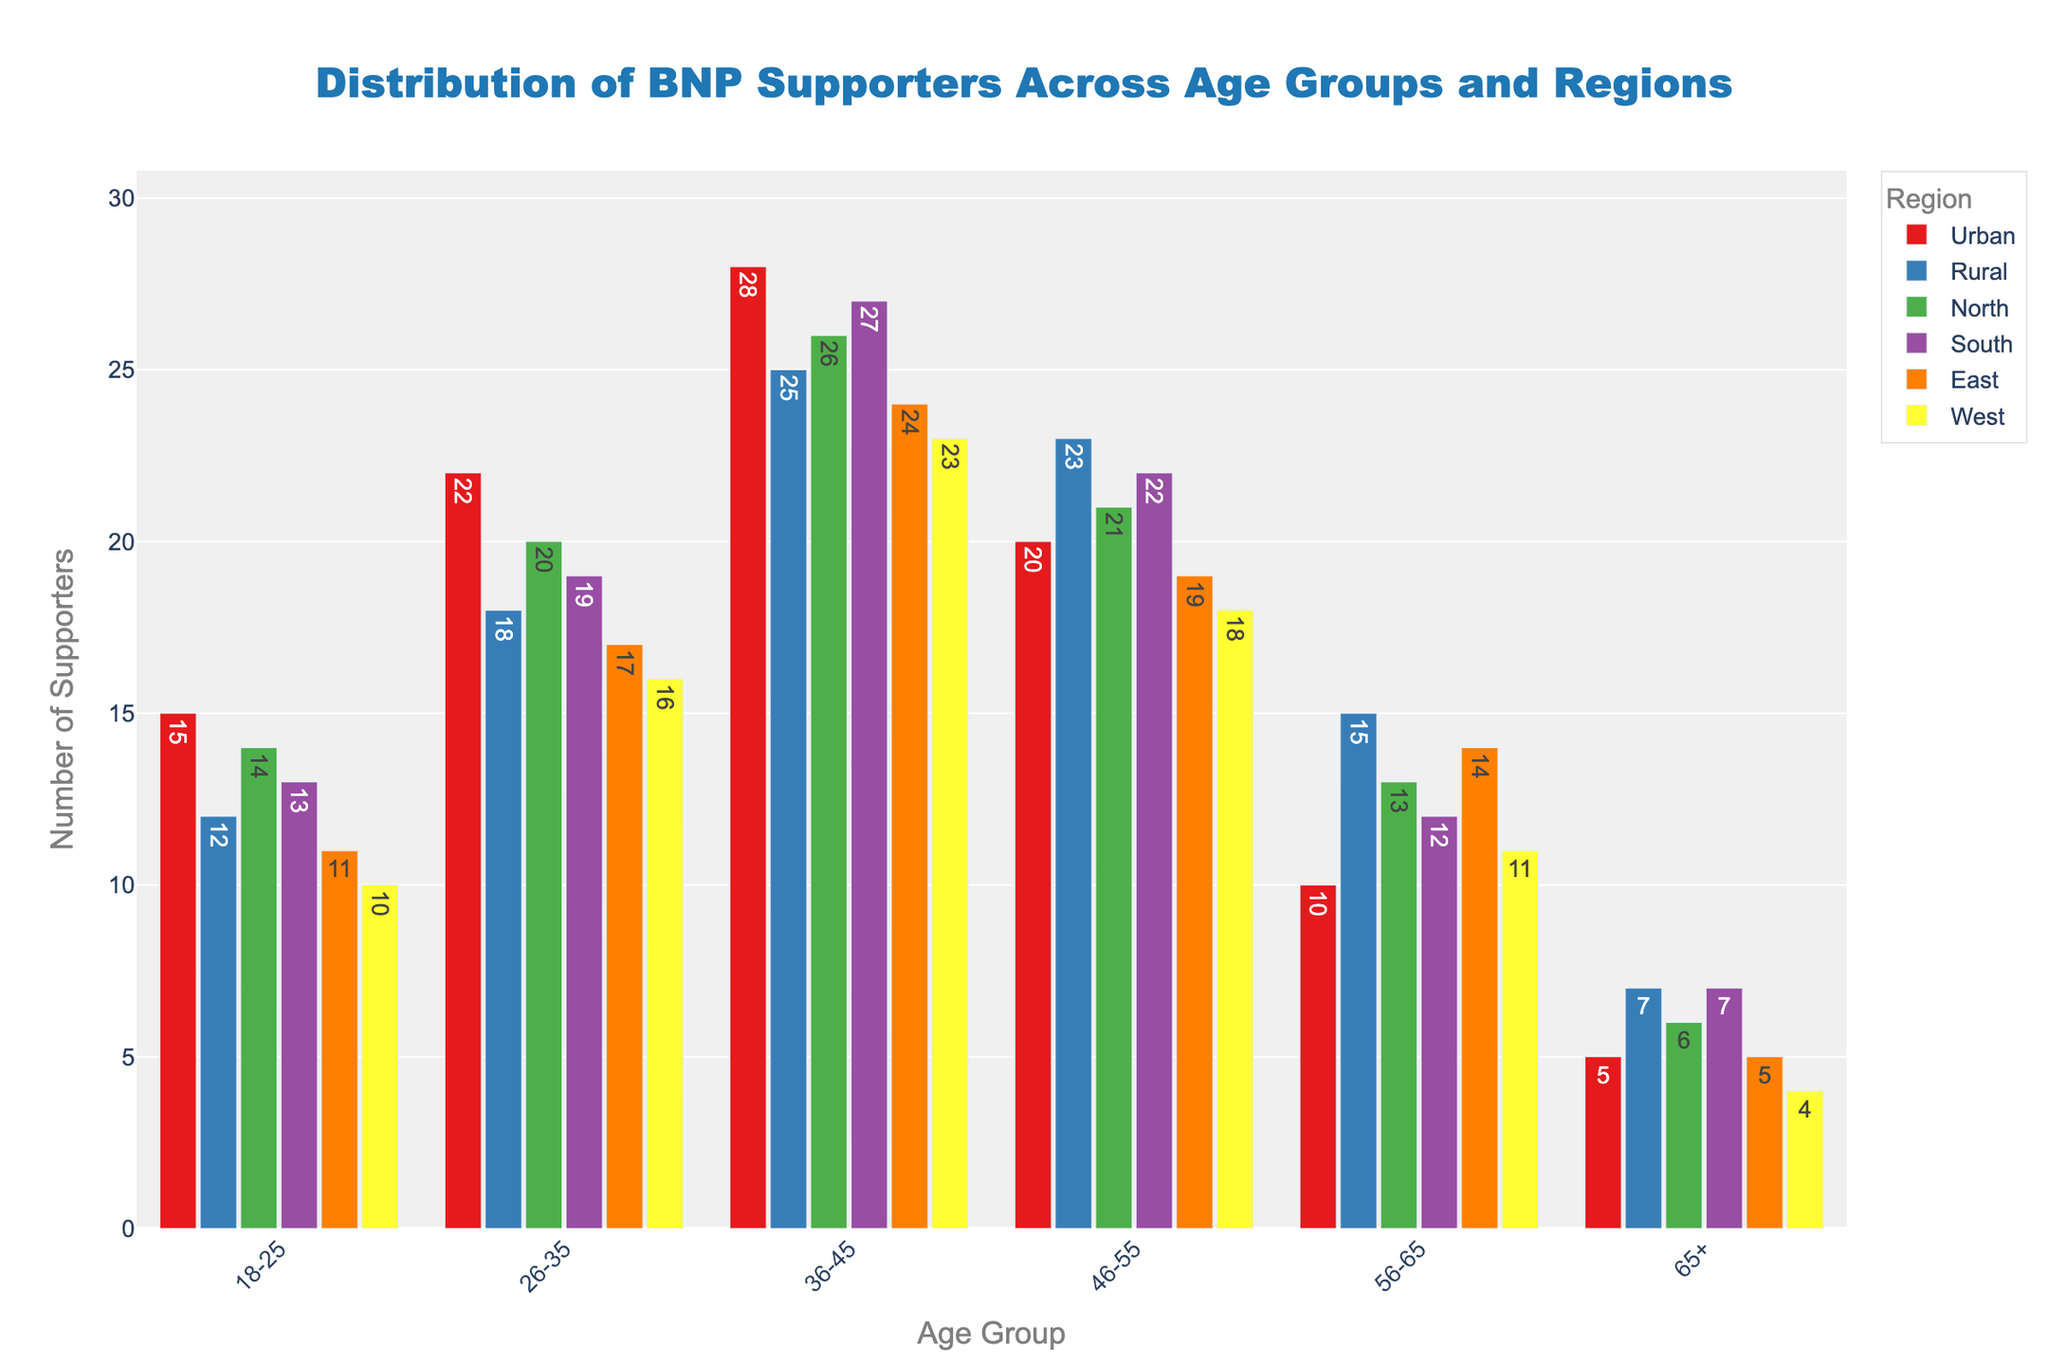Which age group has the highest number of BNP supporters in urban regions? Looking at the bars for urban regions, the age group 36-45 has the highest bar, indicating the largest number of supporters.
Answer: 36-45 Which region has the fewest BNP supporters aged 18-25? Looking at the bars for the age group 18-25, the West region has the lowest bar height, indicating the fewest supporters.
Answer: West What is the total number of BNP supporters in the 26-35 age group across all regions? Sum the number of supporters for the 26-35 age group in all regions: 22 (Urban) + 18 (Rural) + 20 (North) + 19 (South) + 17 (East) + 16 (West) = 112.
Answer: 112 In which region is the difference between supporters in the 36-45 and 46-55 age groups the least? Calculate the difference in the number of supporters between these age groups for each region: 
Urban: 28-20 = 8,
Rural: 25-23 = 2,
North: 26-21 = 5,
South: 27-22 = 5,
East: 24–19 = 5,
West: 23-18 = 5.
The difference is least in the Rural region.
Answer: Rural Which age group has the smallest range in the number of supporters across all regions? Find the range (max-min) for each age group:
18-25: max(15, 12, 14, 13, 11, 10) - min(15, 12, 14, 13, 11, 10) = 15 - 10 = 5,
26-35: max(22, 18, 20, 19, 17, 16) - min(22, 18, 20, 19, 17, 16) = 22 - 16 = 6,
36-45: max(28, 25, 26, 27, 24, 23) - min(28, 25, 26, 27, 24, 23) = 28 - 23 = 5,
46-55: max(23, 23, 21, 22, 19, 18) - min(23, 23, 21, 22, 19, 18) = 23 - 18 = 5,
56-65: max(10, 15, 13, 12, 14, 11) - min(10, 15, 13, 12, 14, 11) = 15 - 10 = 5,
65+: max(5, 7, 6, 7, 5, 4) - min(5, 7, 6, 7, 5, 4) = 7 - 4 = 3,
The age group with the smallest range is 65+.
Answer: 65+ Compare the number of supporters aged 56-65 in the East and West regions. Which region has more supporters? Look at the bars for the 56-65 age group in the East and West regions: East (14) and West (11). East has more supporters.
Answer: East What is the average number of supporters in the South region across all age groups? Sum the number of supporters in the South region: 13 (18-25) + 19 (26-35) + 27 (36-45) + 22 (46-55) + 12 (56-65) + 7 (65+) = 100. Divide by the number of age groups: 100/6 ≈ 16.67.
Answer: 16.67 Which region has the highest bar for the 36-45 age group? The South region has the highest bar for the 36-45 age group, indicating the highest number of supporters.
Answer: South 